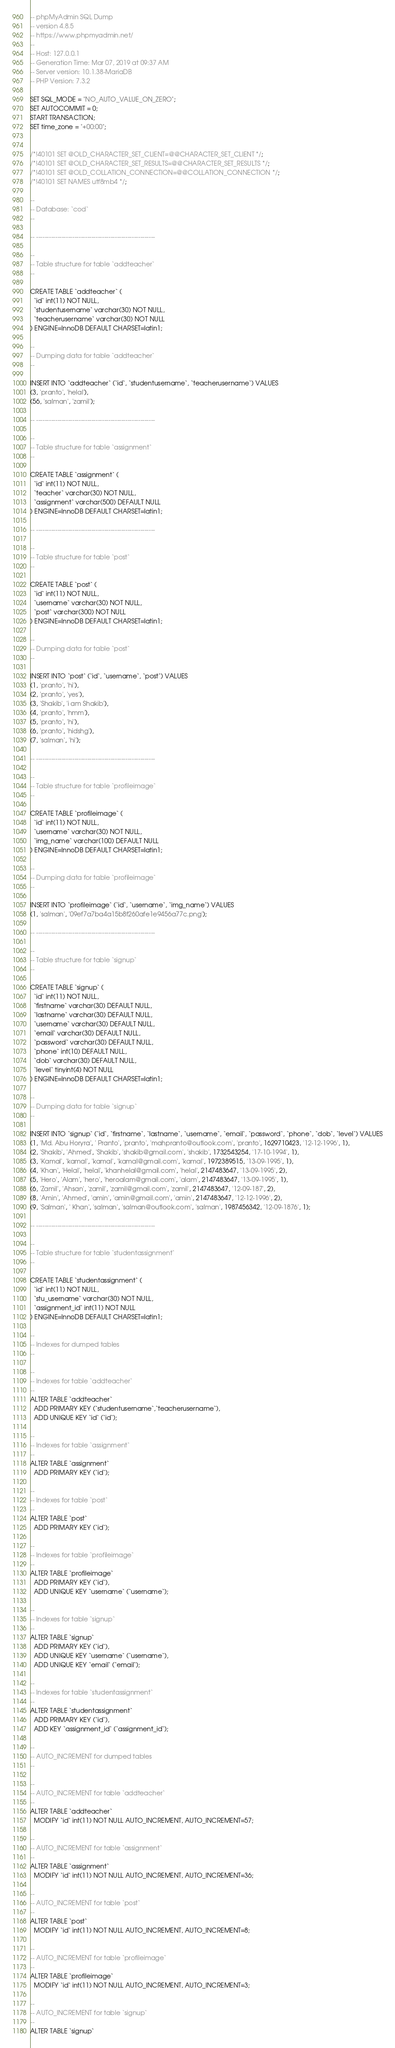Convert code to text. <code><loc_0><loc_0><loc_500><loc_500><_SQL_>-- phpMyAdmin SQL Dump
-- version 4.8.5
-- https://www.phpmyadmin.net/
--
-- Host: 127.0.0.1
-- Generation Time: Mar 07, 2019 at 09:37 AM
-- Server version: 10.1.38-MariaDB
-- PHP Version: 7.3.2

SET SQL_MODE = "NO_AUTO_VALUE_ON_ZERO";
SET AUTOCOMMIT = 0;
START TRANSACTION;
SET time_zone = "+00:00";


/*!40101 SET @OLD_CHARACTER_SET_CLIENT=@@CHARACTER_SET_CLIENT */;
/*!40101 SET @OLD_CHARACTER_SET_RESULTS=@@CHARACTER_SET_RESULTS */;
/*!40101 SET @OLD_COLLATION_CONNECTION=@@COLLATION_CONNECTION */;
/*!40101 SET NAMES utf8mb4 */;

--
-- Database: `cod`
--

-- --------------------------------------------------------

--
-- Table structure for table `addteacher`
--

CREATE TABLE `addteacher` (
  `id` int(11) NOT NULL,
  `studentusername` varchar(30) NOT NULL,
  `teacherusername` varchar(30) NOT NULL
) ENGINE=InnoDB DEFAULT CHARSET=latin1;

--
-- Dumping data for table `addteacher`
--

INSERT INTO `addteacher` (`id`, `studentusername`, `teacherusername`) VALUES
(3, 'pranto', 'helal'),
(56, 'salman', 'zamil');

-- --------------------------------------------------------

--
-- Table structure for table `assignment`
--

CREATE TABLE `assignment` (
  `id` int(11) NOT NULL,
  `teacher` varchar(30) NOT NULL,
  `assignment` varchar(500) DEFAULT NULL
) ENGINE=InnoDB DEFAULT CHARSET=latin1;

-- --------------------------------------------------------

--
-- Table structure for table `post`
--

CREATE TABLE `post` (
  `id` int(11) NOT NULL,
  `username` varchar(30) NOT NULL,
  `post` varchar(300) NOT NULL
) ENGINE=InnoDB DEFAULT CHARSET=latin1;

--
-- Dumping data for table `post`
--

INSERT INTO `post` (`id`, `username`, `post`) VALUES
(1, 'pranto', 'hi'),
(2, 'pranto', 'yes'),
(3, 'Shakib', 'i am Shakib'),
(4, 'pranto', 'hmm'),
(5, 'pranto', 'hi'),
(6, 'pranto', 'hidshg'),
(7, 'salman', 'hi');

-- --------------------------------------------------------

--
-- Table structure for table `profileimage`
--

CREATE TABLE `profileimage` (
  `id` int(11) NOT NULL,
  `username` varchar(30) NOT NULL,
  `img_name` varchar(100) DEFAULT NULL
) ENGINE=InnoDB DEFAULT CHARSET=latin1;

--
-- Dumping data for table `profileimage`
--

INSERT INTO `profileimage` (`id`, `username`, `img_name`) VALUES
(1, 'salman', '09ef7a7ba4a15b8f260afe1e9456a77c.png');

-- --------------------------------------------------------

--
-- Table structure for table `signup`
--

CREATE TABLE `signup` (
  `id` int(11) NOT NULL,
  `firstname` varchar(30) DEFAULT NULL,
  `lastname` varchar(30) DEFAULT NULL,
  `username` varchar(30) DEFAULT NULL,
  `email` varchar(30) DEFAULT NULL,
  `password` varchar(30) DEFAULT NULL,
  `phone` int(10) DEFAULT NULL,
  `dob` varchar(30) DEFAULT NULL,
  `level` tinyint(4) NOT NULL
) ENGINE=InnoDB DEFAULT CHARSET=latin1;

--
-- Dumping data for table `signup`
--

INSERT INTO `signup` (`id`, `firstname`, `lastname`, `username`, `email`, `password`, `phone`, `dob`, `level`) VALUES
(1, 'Md. Abu Horyra', ' Pranto', 'pranto', 'mahpranto@outlook.com', 'pranto', 1629710423, '12-12-1996', 1),
(2, 'Shakib', 'Ahmed', 'Shakib', 'shakib@gmail.com', 'shakib', 1732543254, '17-10-1994', 1),
(3, 'Kamal', 'kamal', 'kamal', 'kamal@gmail.com', 'kamal', 1972389515, '13-09-1995', 1),
(4, 'Khan', 'Helal', 'helal', 'khanhelal@gmail.com', 'helal', 2147483647, '13-09-1995', 2),
(5, 'Hero', 'Alam', 'hero', 'heroalam@gmail.com', 'alam', 2147483647, '13-09-1995', 1),
(6, 'Zamil', 'Ahsan', 'zamil', 'zamil@gmail.com', 'zamil', 2147483647, '12-09-187', 2),
(8, 'Amin', 'Ahmed', 'amin', 'amin@gmail.com', 'amin', 2147483647, '12-12-1996', 2),
(9, 'Salman', ' Khan', 'salman', 'salman@outlook.com', 'salman', 1987456342, '12-09-1876', 1);

-- --------------------------------------------------------

--
-- Table structure for table `studentassignment`
--

CREATE TABLE `studentassignment` (
  `id` int(11) NOT NULL,
  `stu_username` varchar(30) NOT NULL,
  `assignment_id` int(11) NOT NULL
) ENGINE=InnoDB DEFAULT CHARSET=latin1;

--
-- Indexes for dumped tables
--

--
-- Indexes for table `addteacher`
--
ALTER TABLE `addteacher`
  ADD PRIMARY KEY (`studentusername`,`teacherusername`),
  ADD UNIQUE KEY `id` (`id`);

--
-- Indexes for table `assignment`
--
ALTER TABLE `assignment`
  ADD PRIMARY KEY (`id`);

--
-- Indexes for table `post`
--
ALTER TABLE `post`
  ADD PRIMARY KEY (`id`);

--
-- Indexes for table `profileimage`
--
ALTER TABLE `profileimage`
  ADD PRIMARY KEY (`id`),
  ADD UNIQUE KEY `username` (`username`);

--
-- Indexes for table `signup`
--
ALTER TABLE `signup`
  ADD PRIMARY KEY (`id`),
  ADD UNIQUE KEY `username` (`username`),
  ADD UNIQUE KEY `email` (`email`);

--
-- Indexes for table `studentassignment`
--
ALTER TABLE `studentassignment`
  ADD PRIMARY KEY (`id`),
  ADD KEY `assignment_id` (`assignment_id`);

--
-- AUTO_INCREMENT for dumped tables
--

--
-- AUTO_INCREMENT for table `addteacher`
--
ALTER TABLE `addteacher`
  MODIFY `id` int(11) NOT NULL AUTO_INCREMENT, AUTO_INCREMENT=57;

--
-- AUTO_INCREMENT for table `assignment`
--
ALTER TABLE `assignment`
  MODIFY `id` int(11) NOT NULL AUTO_INCREMENT, AUTO_INCREMENT=36;

--
-- AUTO_INCREMENT for table `post`
--
ALTER TABLE `post`
  MODIFY `id` int(11) NOT NULL AUTO_INCREMENT, AUTO_INCREMENT=8;

--
-- AUTO_INCREMENT for table `profileimage`
--
ALTER TABLE `profileimage`
  MODIFY `id` int(11) NOT NULL AUTO_INCREMENT, AUTO_INCREMENT=3;

--
-- AUTO_INCREMENT for table `signup`
--
ALTER TABLE `signup`</code> 